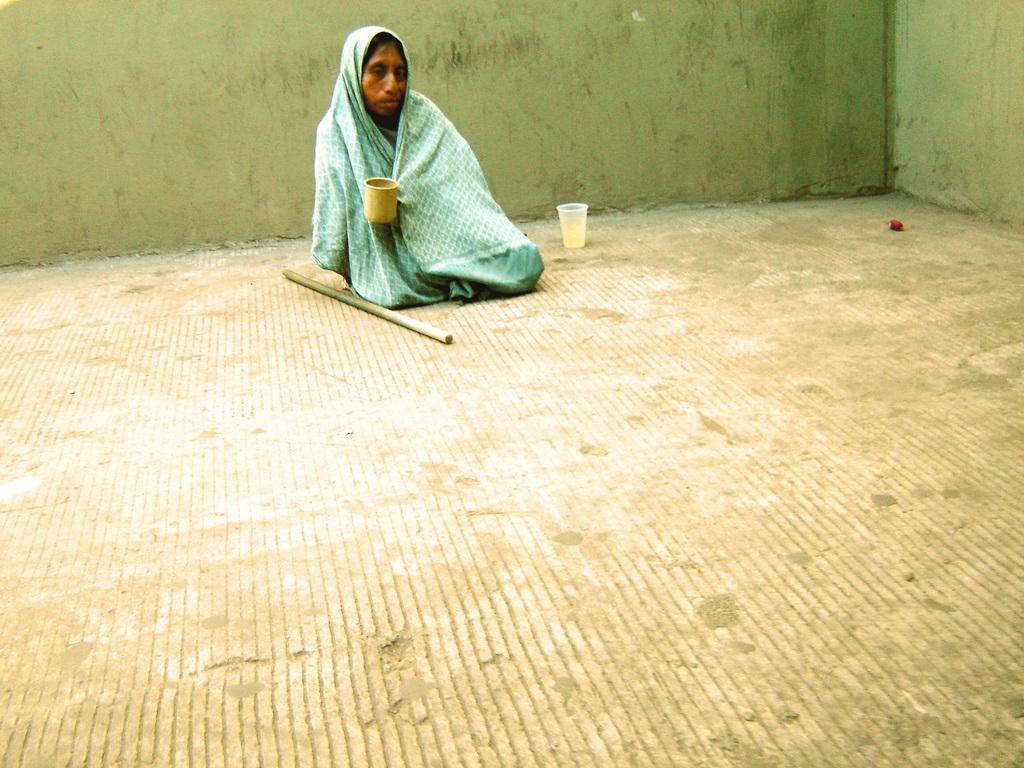Describe this image in one or two sentences. In the image we can see there is a person sitting on the ground and he wrapped blanket. The person is holding mug in his hand and there is a stick kept on the floor. There is a glass of water kept on the floor. 